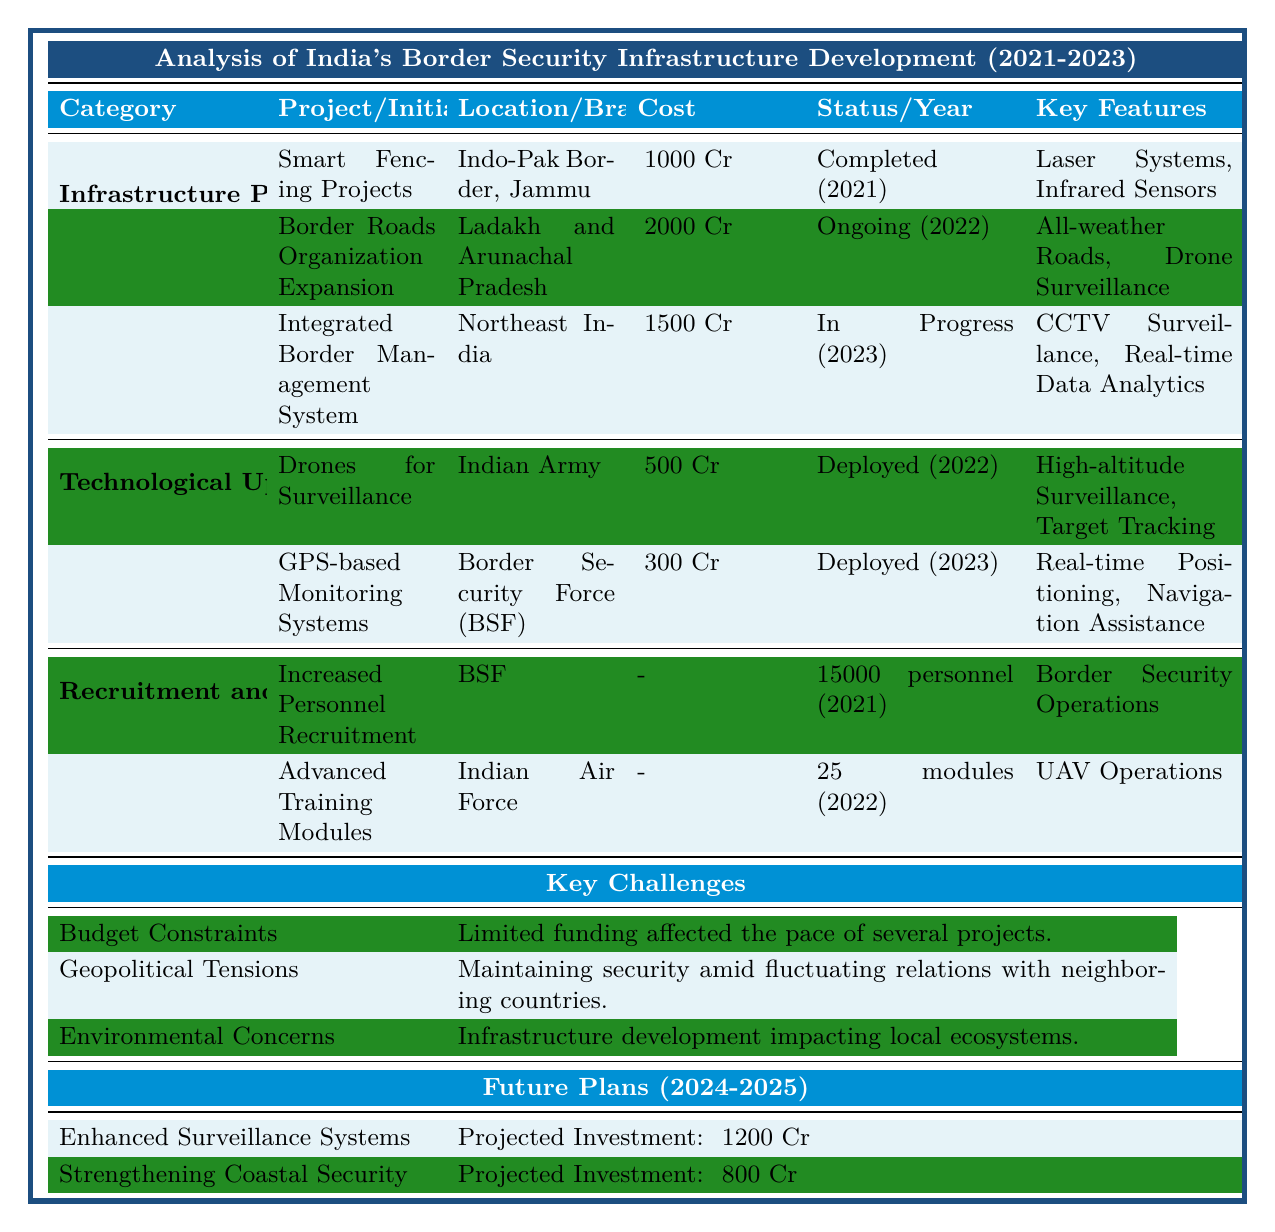What is the total cost of all Infrastructure Projects listed? The costs of the three listed infrastructure projects are ₹1000 Cr, ₹2000 Cr, and ₹1500 Cr. Adding these together: 1000 + 2000 + 1500 = 4500.
Answer: ₹4500 Cr Which project has been completed first, and what was its cost? The Smart Fencing Projects were completed in 2021, and its cost was ₹1000 Cr.
Answer: Smart Fencing Projects, ₹1000 Cr How many personnel were recruited under the Increased Personnel Recruitment initiative? The Increased Personnel Recruitment initiative indicates that 15,000 personnel were recruited.
Answer: 15000 personnel Is the Integrated Border Management System project ongoing? The completion status of the Integrated Border Management System is "In Progress," indicating it is still ongoing.
Answer: Yes What technology is used in the Border Roads Organization Expansion project? This project uses All-weather Roads and Drone Surveillance technologies.
Answer: All-weather Roads, Drone Surveillance What has been the total projected investment for future plans? The total projected investment for the two future plans is ₹1200 Cr (Enhanced Surveillance Systems) plus ₹800 Cr (Strengthening Coastal Security), giving a total of 1200 + 800 = 2000.
Answer: ₹2000 Cr Which technological upgrade was implemented by the Border Security Force? The GPS-based Monitoring Systems were implemented by the Border Security Force (BSF).
Answer: GPS-based Monitoring Systems Did any of the recruitment initiatives focus on the Indian Army? The recruitment initiatives listed focus on the BSF and Indian Air Force, but there is no mention of the Indian Army in recruitment.
Answer: No What challenges mention budget constraints and their impact? The challenge related to budget constraints states that limited funding affected the pace of several projects.
Answer: Budget Constraints: Limited funding affected project pace Which project emphasizes the use of high-altitude surveillance? The Drones for Surveillance project emphasizes the use of high-altitude surveillance capabilities.
Answer: Drones for Surveillance 